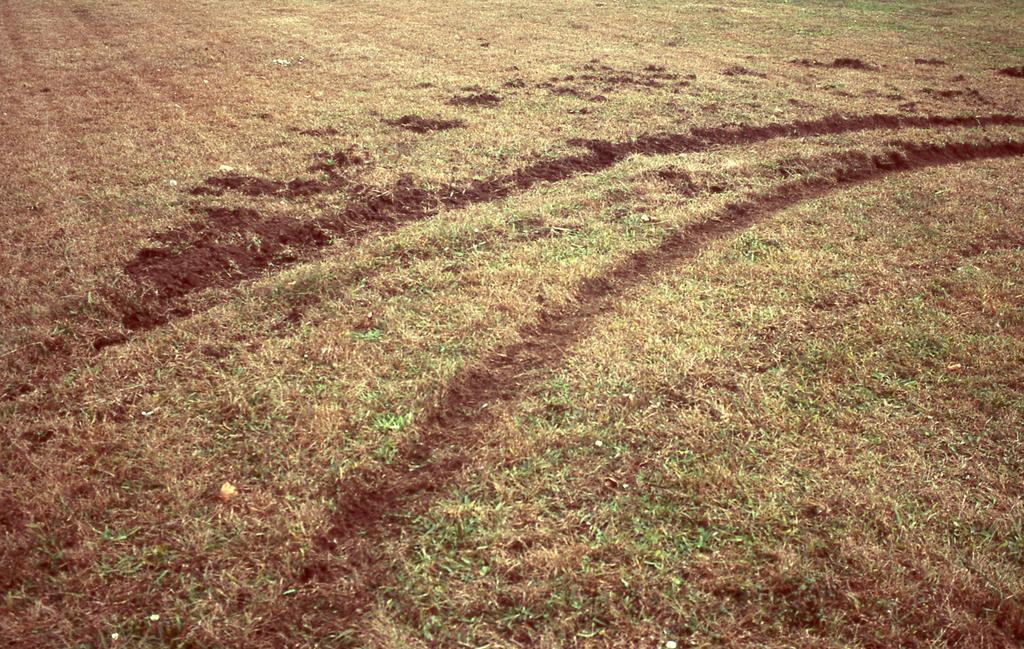What type of landscape is shown in the image? The image depicts a field. What is the condition of the grass in the field? There is dry grass in the field. Can you describe the vegetation in the field? There is grass in the field. What is the ground made of in the field? Soil is present in the field. What type of soup is being served in the field? There is no soup present in the image; it depicts a field with dry grass and soil. What color is the thread used to decorate the flag in the field? There is no flag present in the image; it only shows a field with dry grass and soil. 